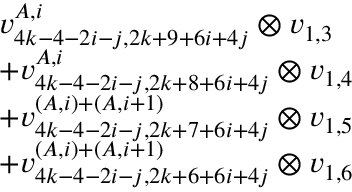Convert formula to latex. <formula><loc_0><loc_0><loc_500><loc_500>\begin{array} { r l } & { v _ { 4 k - 4 - 2 i - j , 2 k + 9 + 6 i + 4 j } ^ { A , i } \otimes v _ { 1 , 3 } } \\ & { + v _ { 4 k - 4 - 2 i - j , 2 k + 8 + 6 i + 4 j } ^ { A , i } \otimes v _ { 1 , 4 } } \\ & { + v _ { 4 k - 4 - 2 i - j , 2 k + 7 + 6 i + 4 j } ^ { ( A , i ) + ( A , i + 1 ) } \otimes v _ { 1 , 5 } } \\ & { + v _ { 4 k - 4 - 2 i - j , 2 k + 6 + 6 i + 4 j } ^ { ( A , i ) + ( A , i + 1 ) } \otimes v _ { 1 , 6 } } \end{array}</formula> 